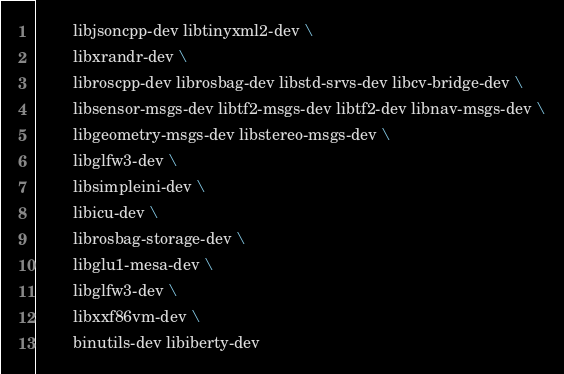Convert code to text. <code><loc_0><loc_0><loc_500><loc_500><_Dockerfile_>		libjsoncpp-dev libtinyxml2-dev \
		libxrandr-dev \
		libroscpp-dev librosbag-dev libstd-srvs-dev libcv-bridge-dev \
		libsensor-msgs-dev libtf2-msgs-dev libtf2-dev libnav-msgs-dev \
		libgeometry-msgs-dev libstereo-msgs-dev \
		libglfw3-dev \
		libsimpleini-dev \
		libicu-dev \
		librosbag-storage-dev \
		libglu1-mesa-dev \
		libglfw3-dev \
		libxxf86vm-dev \
		binutils-dev libiberty-dev
</code> 